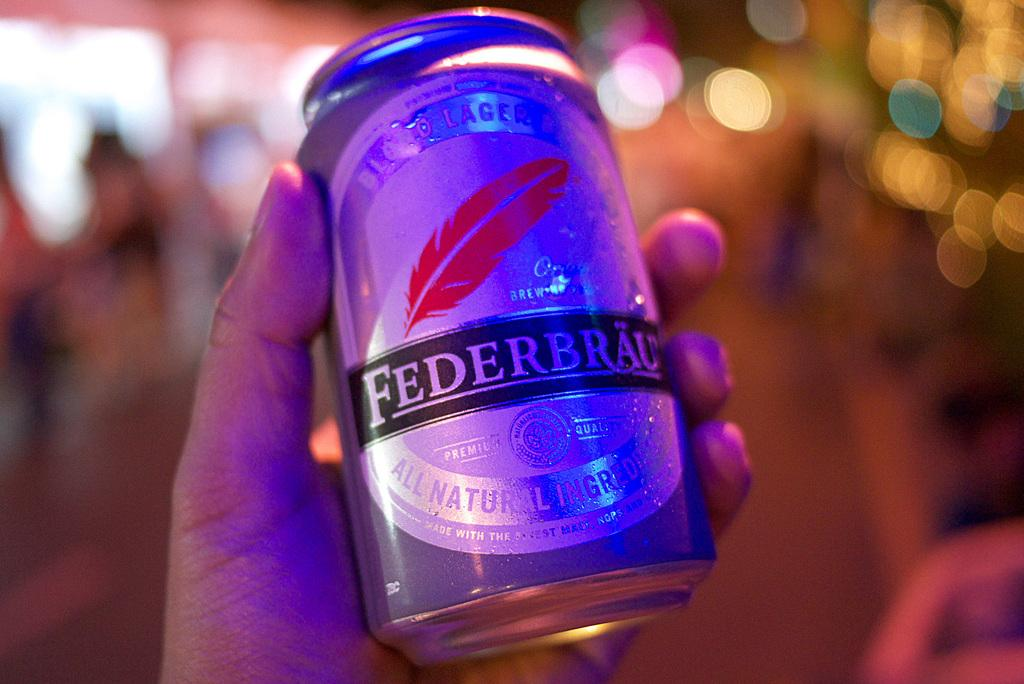<image>
Present a compact description of the photo's key features. A bluish can of Federbrau brewed Malt with all natural ingredients 